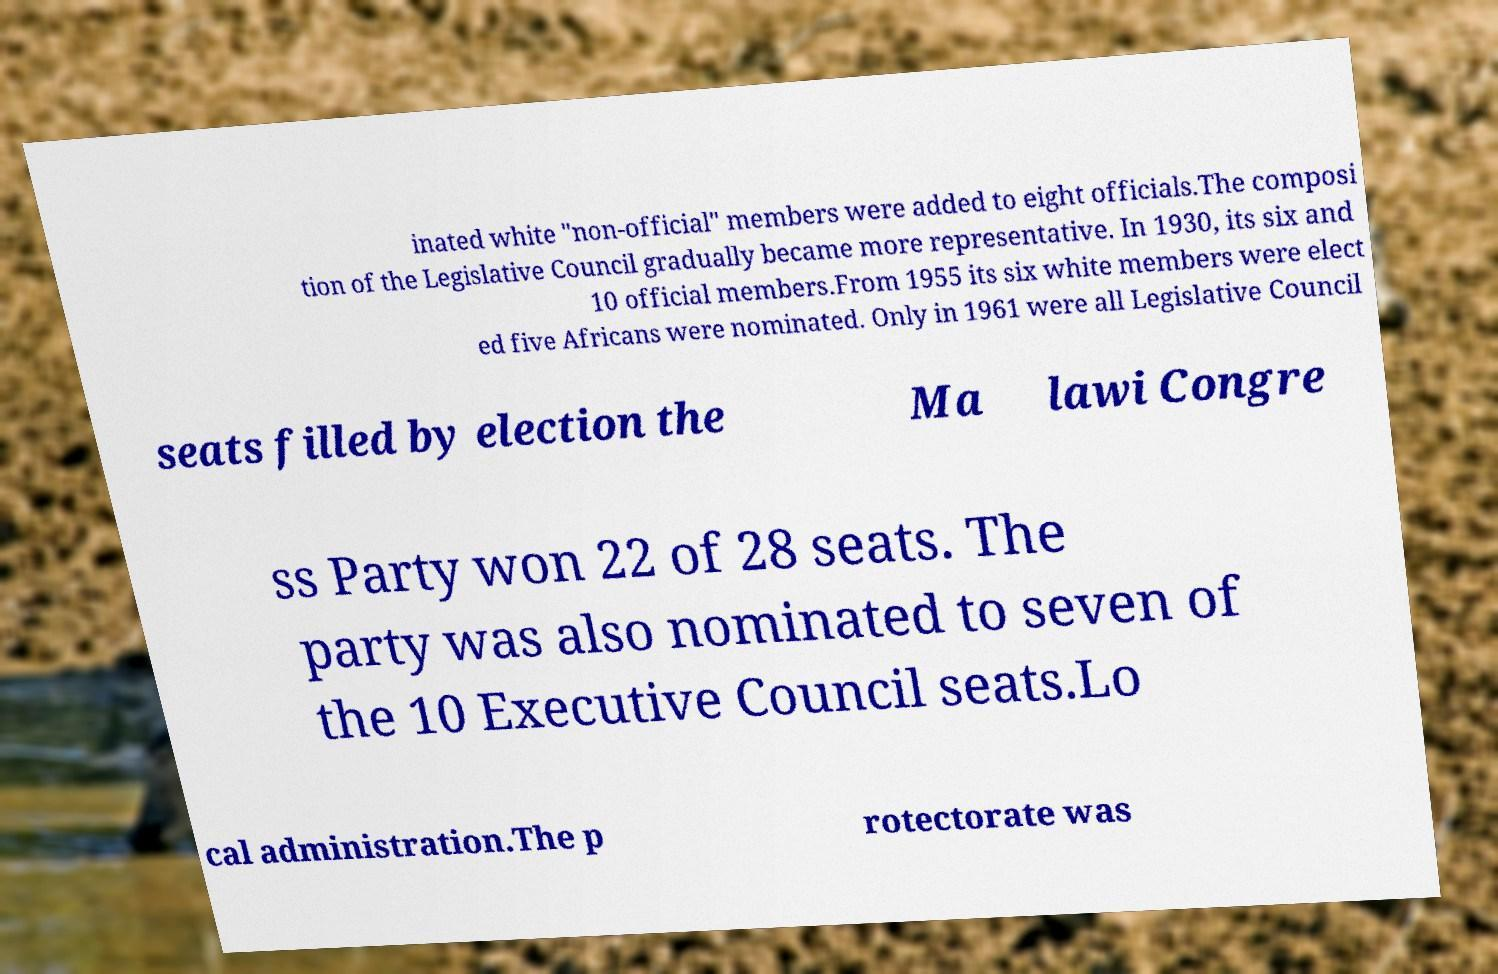Could you assist in decoding the text presented in this image and type it out clearly? inated white "non-official" members were added to eight officials.The composi tion of the Legislative Council gradually became more representative. In 1930, its six and 10 official members.From 1955 its six white members were elect ed five Africans were nominated. Only in 1961 were all Legislative Council seats filled by election the Ma lawi Congre ss Party won 22 of 28 seats. The party was also nominated to seven of the 10 Executive Council seats.Lo cal administration.The p rotectorate was 